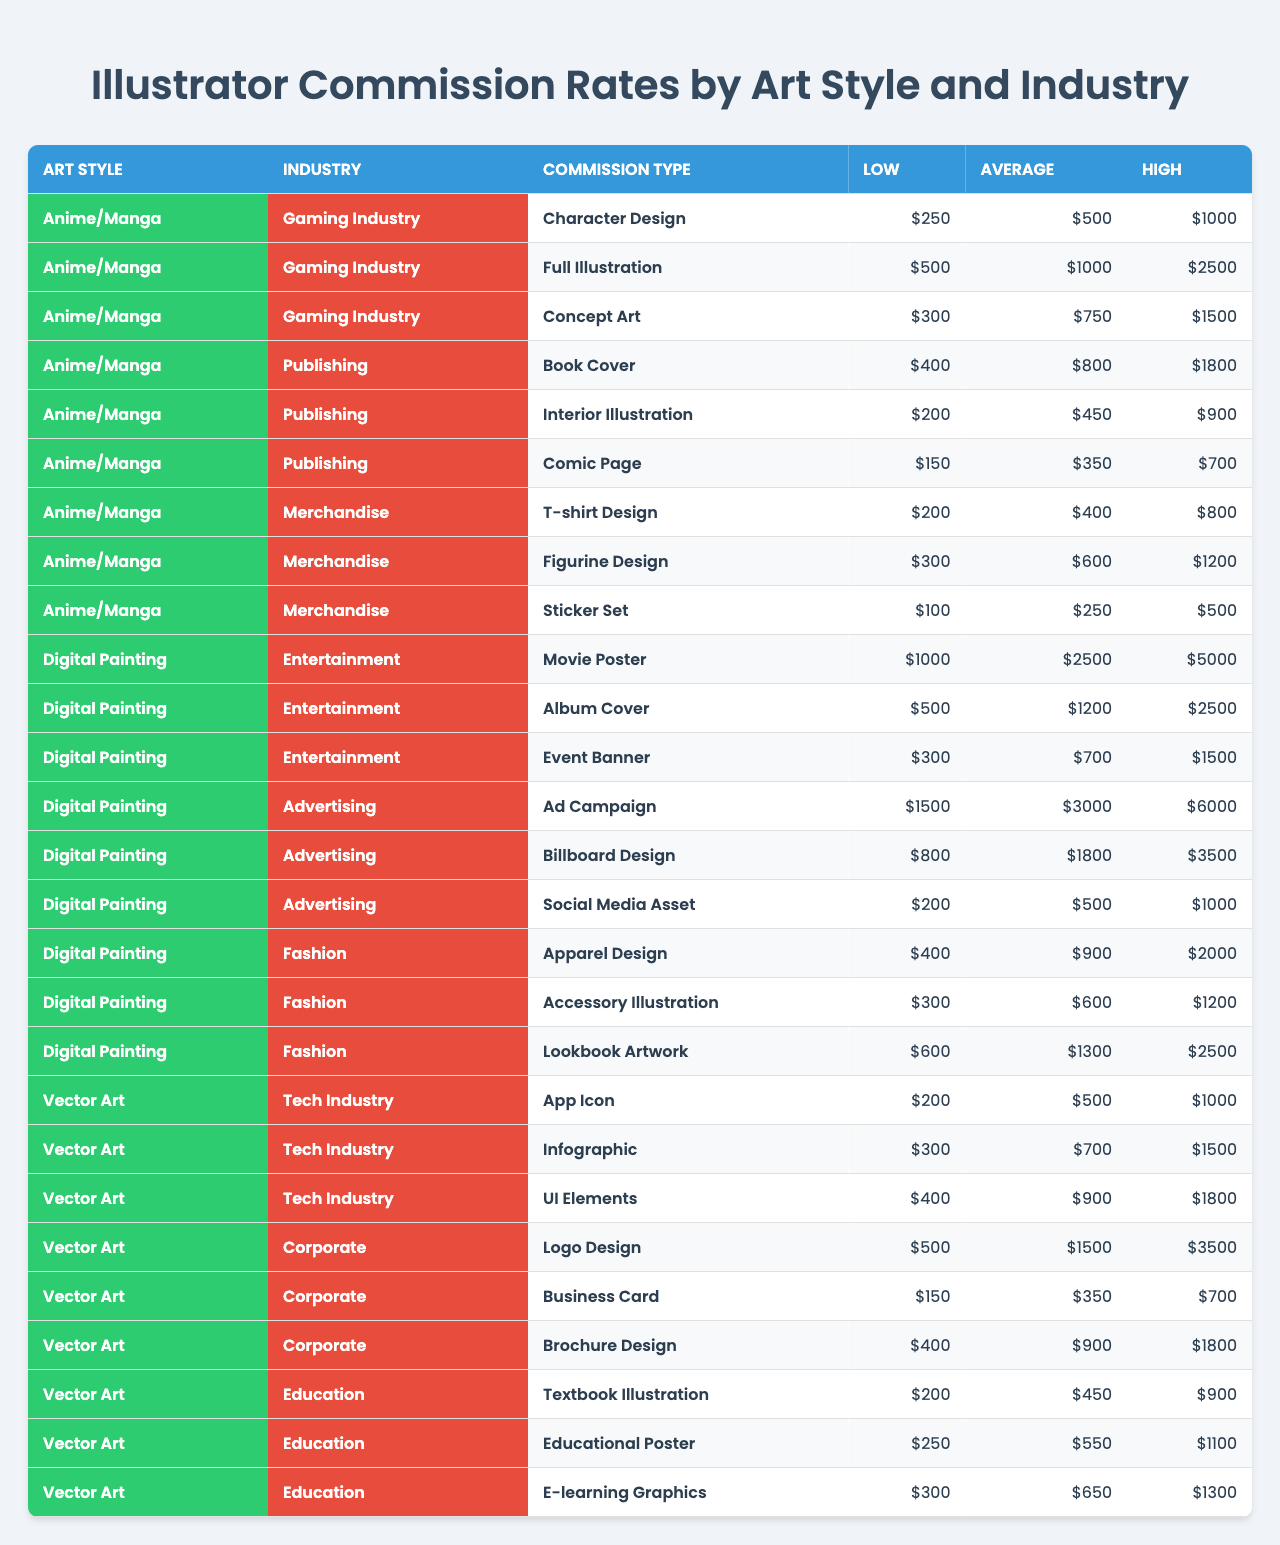What is the highest average earning for a commission in the Gaming Industry? The table lists the "Average" earning for commissions in the Gaming Industry under the "Anime/Manga" art style. The highest average earning is for "Full Illustration," which is $1000.
Answer: $1000 Which commission type has the highest low rate in the Digital Painting style? In the Digital Painting category, the "Ad Campaign" under Advertising shows the highest low rate at $1500.
Answer: $1500 How much does a "Comic Page" illustration in the Publishing industry cost on average? Referring to the "Comic Page" commission under the Publishing industry, the average cost is $350.
Answer: $350 What is the total maximum earning for all commission types in the Tech Industry? Summing the high rates for each commission type: "App Icon" ($1000), "Infographic" ($1500), and "UI Elements" ($1800) gives: $1000 + $1500 + $1800 = $4300.
Answer: $4300 Is the average earning for "Character Design" higher than that of "T-shirt Design"? The average earning for "Character Design" is $500, while "T-shirt Design" is $400. Therefore, $500 > $400 confirms that it is higher.
Answer: Yes What's the difference between the highest high rate in the Corporate industry and the lowest low rate in the Education industry? The highest high rate in the Corporate industry is "Logo Design" at $3500, while the lowest low rate in Education industry is "Textbook Illustration" at $200. Thus, $3500 - $200 = $3300.
Answer: $3300 What is the average rate for "Accessory Illustration" in Fashion? The average rate for "Accessory Illustration" is $600 as listed under the Fashion industry.
Answer: $600 If you sum the average rates for all commission types in the Merchandise sector, what do you get? The sums are as follows: T-shirt Design ($400) + Figurine Design ($600) + Sticker Set ($250) = $400 + $600 + $250 = $1250.
Answer: $1250 Are there any commissions in the Education industry that have high rates exceeding $1500? Checking the high rates listed, "E-learning Graphics" shows a high rate of $1300, which does not exceed $1500, confirming that there are no commissions above that amount.
Answer: No Which art style and industry combination has the lowest low rate, and what is it? The lowest low rate in the table is found in "Sticker Set" under the Merchandise industry with a low rate of $100.
Answer: $100 